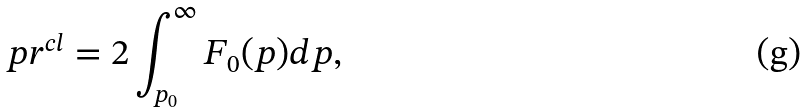Convert formula to latex. <formula><loc_0><loc_0><loc_500><loc_500>p r ^ { c l } = 2 \int _ { p _ { 0 } } ^ { \infty } { F _ { 0 } ( p ) } d p ,</formula> 